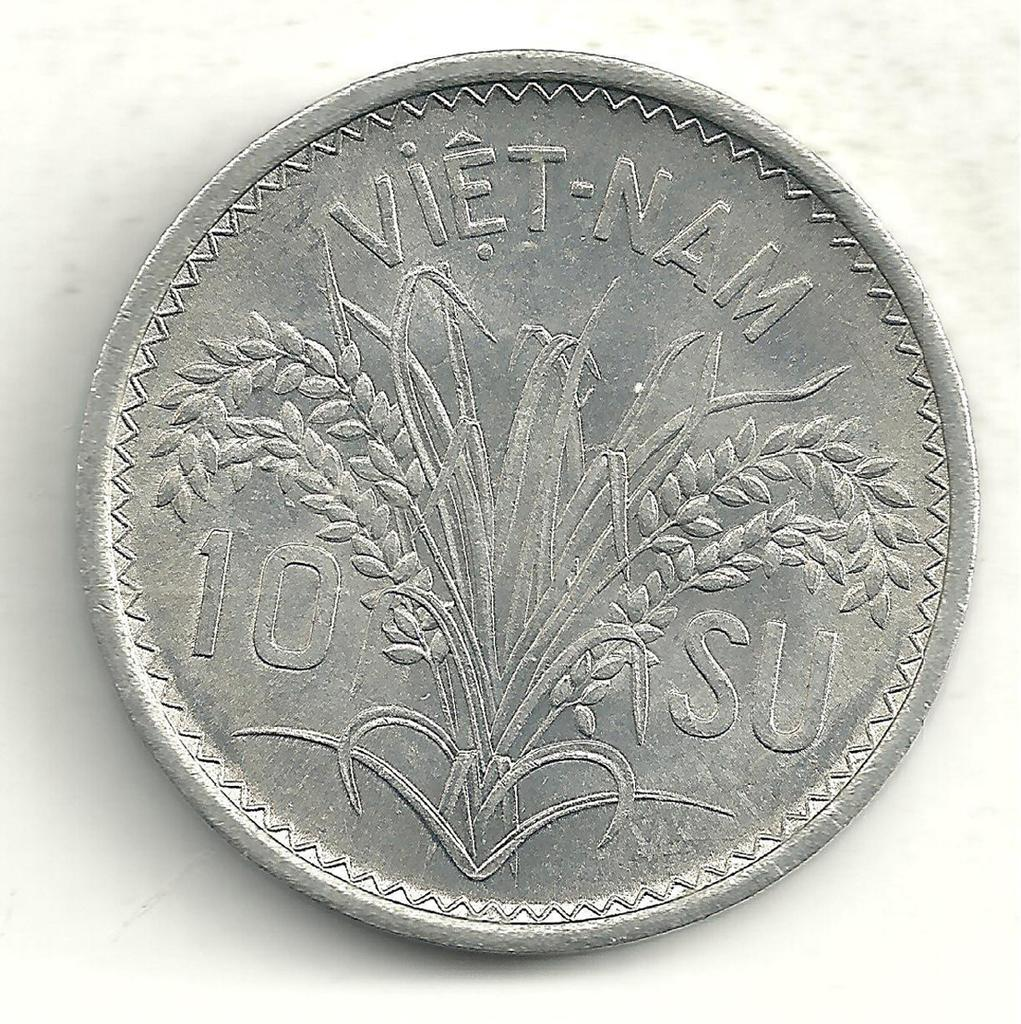<image>
Provide a brief description of the given image. a silver coin that says 'viet-nam' on it 